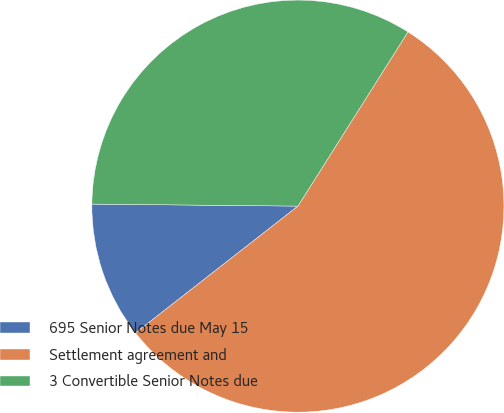Convert chart. <chart><loc_0><loc_0><loc_500><loc_500><pie_chart><fcel>695 Senior Notes due May 15<fcel>Settlement agreement and<fcel>3 Convertible Senior Notes due<nl><fcel>10.71%<fcel>55.48%<fcel>33.81%<nl></chart> 